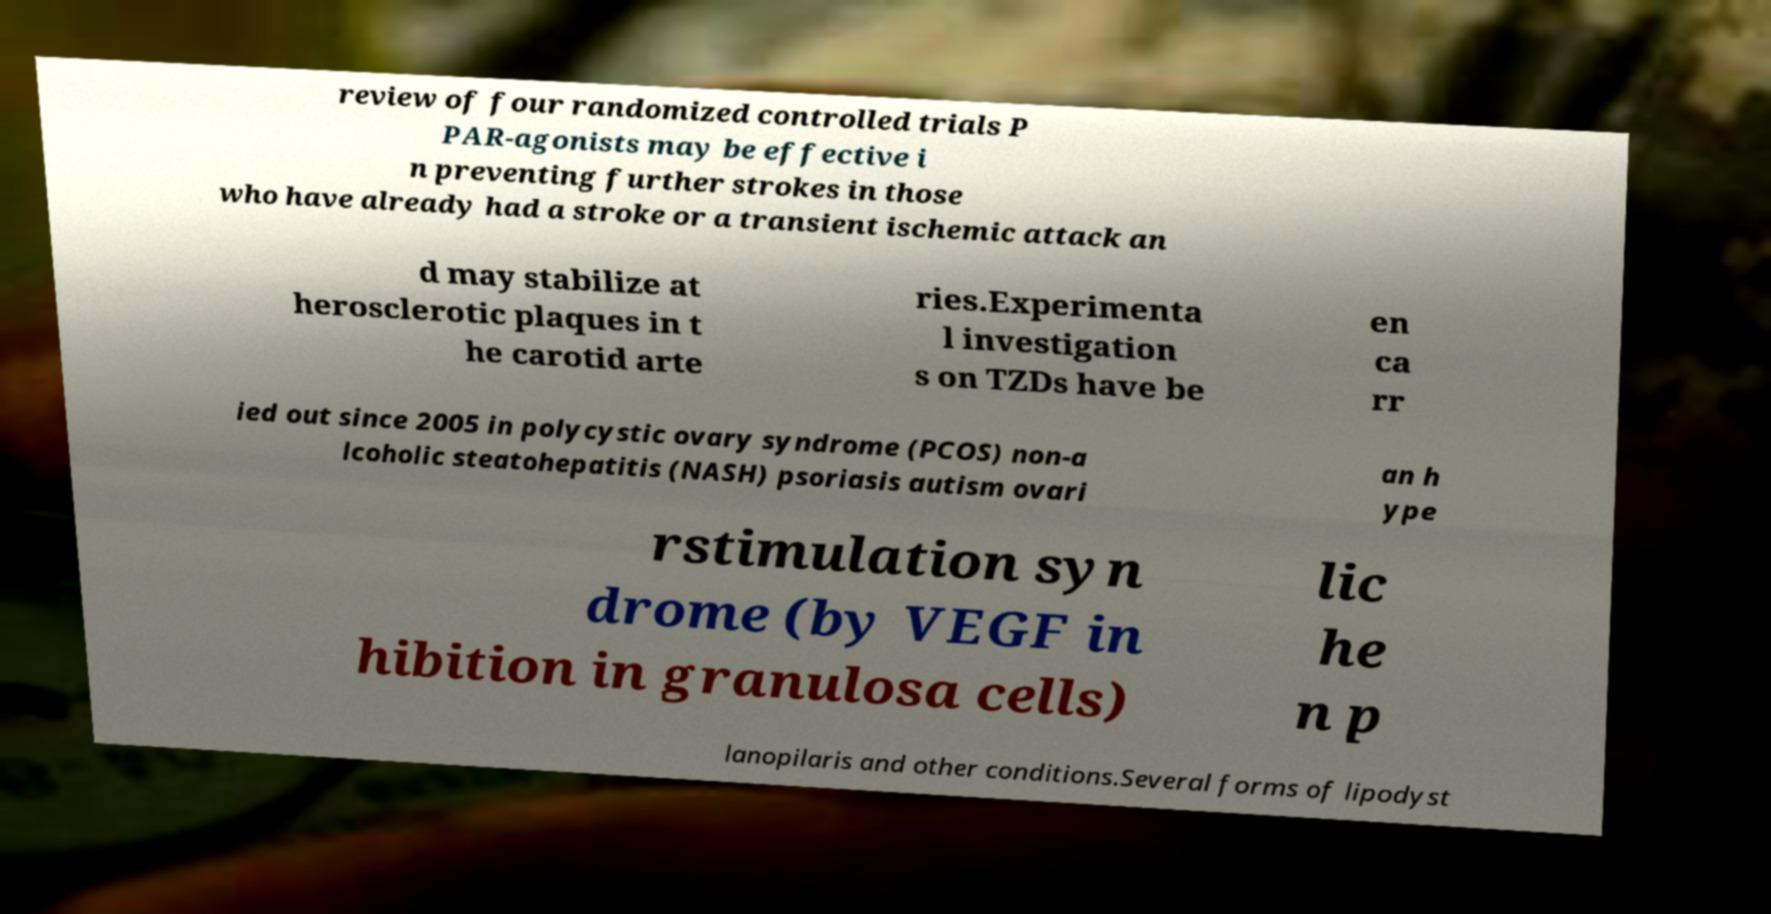Can you accurately transcribe the text from the provided image for me? review of four randomized controlled trials P PAR-agonists may be effective i n preventing further strokes in those who have already had a stroke or a transient ischemic attack an d may stabilize at herosclerotic plaques in t he carotid arte ries.Experimenta l investigation s on TZDs have be en ca rr ied out since 2005 in polycystic ovary syndrome (PCOS) non-a lcoholic steatohepatitis (NASH) psoriasis autism ovari an h ype rstimulation syn drome (by VEGF in hibition in granulosa cells) lic he n p lanopilaris and other conditions.Several forms of lipodyst 